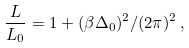<formula> <loc_0><loc_0><loc_500><loc_500>\frac { L } { L _ { 0 } } = 1 + ( \beta \Delta _ { 0 } ) ^ { 2 } / ( 2 \pi ) ^ { 2 } \, ,</formula> 